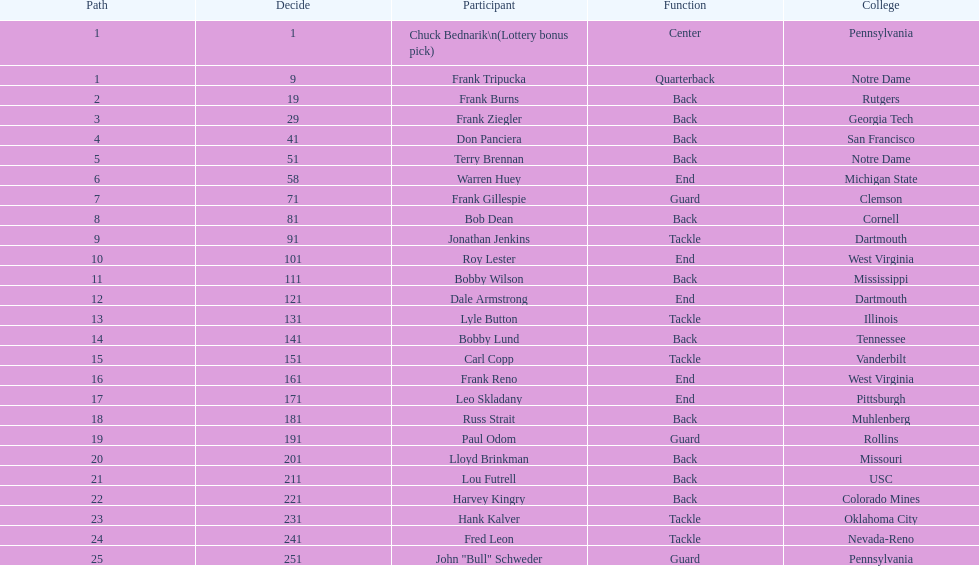What was the position that most of the players had? Back. I'm looking to parse the entire table for insights. Could you assist me with that? {'header': ['Path', 'Decide', 'Participant', 'Function', 'College'], 'rows': [['1', '1', 'Chuck Bednarik\\n(Lottery bonus pick)', 'Center', 'Pennsylvania'], ['1', '9', 'Frank Tripucka', 'Quarterback', 'Notre Dame'], ['2', '19', 'Frank Burns', 'Back', 'Rutgers'], ['3', '29', 'Frank Ziegler', 'Back', 'Georgia Tech'], ['4', '41', 'Don Panciera', 'Back', 'San Francisco'], ['5', '51', 'Terry Brennan', 'Back', 'Notre Dame'], ['6', '58', 'Warren Huey', 'End', 'Michigan State'], ['7', '71', 'Frank Gillespie', 'Guard', 'Clemson'], ['8', '81', 'Bob Dean', 'Back', 'Cornell'], ['9', '91', 'Jonathan Jenkins', 'Tackle', 'Dartmouth'], ['10', '101', 'Roy Lester', 'End', 'West Virginia'], ['11', '111', 'Bobby Wilson', 'Back', 'Mississippi'], ['12', '121', 'Dale Armstrong', 'End', 'Dartmouth'], ['13', '131', 'Lyle Button', 'Tackle', 'Illinois'], ['14', '141', 'Bobby Lund', 'Back', 'Tennessee'], ['15', '151', 'Carl Copp', 'Tackle', 'Vanderbilt'], ['16', '161', 'Frank Reno', 'End', 'West Virginia'], ['17', '171', 'Leo Skladany', 'End', 'Pittsburgh'], ['18', '181', 'Russ Strait', 'Back', 'Muhlenberg'], ['19', '191', 'Paul Odom', 'Guard', 'Rollins'], ['20', '201', 'Lloyd Brinkman', 'Back', 'Missouri'], ['21', '211', 'Lou Futrell', 'Back', 'USC'], ['22', '221', 'Harvey Kingry', 'Back', 'Colorado Mines'], ['23', '231', 'Hank Kalver', 'Tackle', 'Oklahoma City'], ['24', '241', 'Fred Leon', 'Tackle', 'Nevada-Reno'], ['25', '251', 'John "Bull" Schweder', 'Guard', 'Pennsylvania']]} 